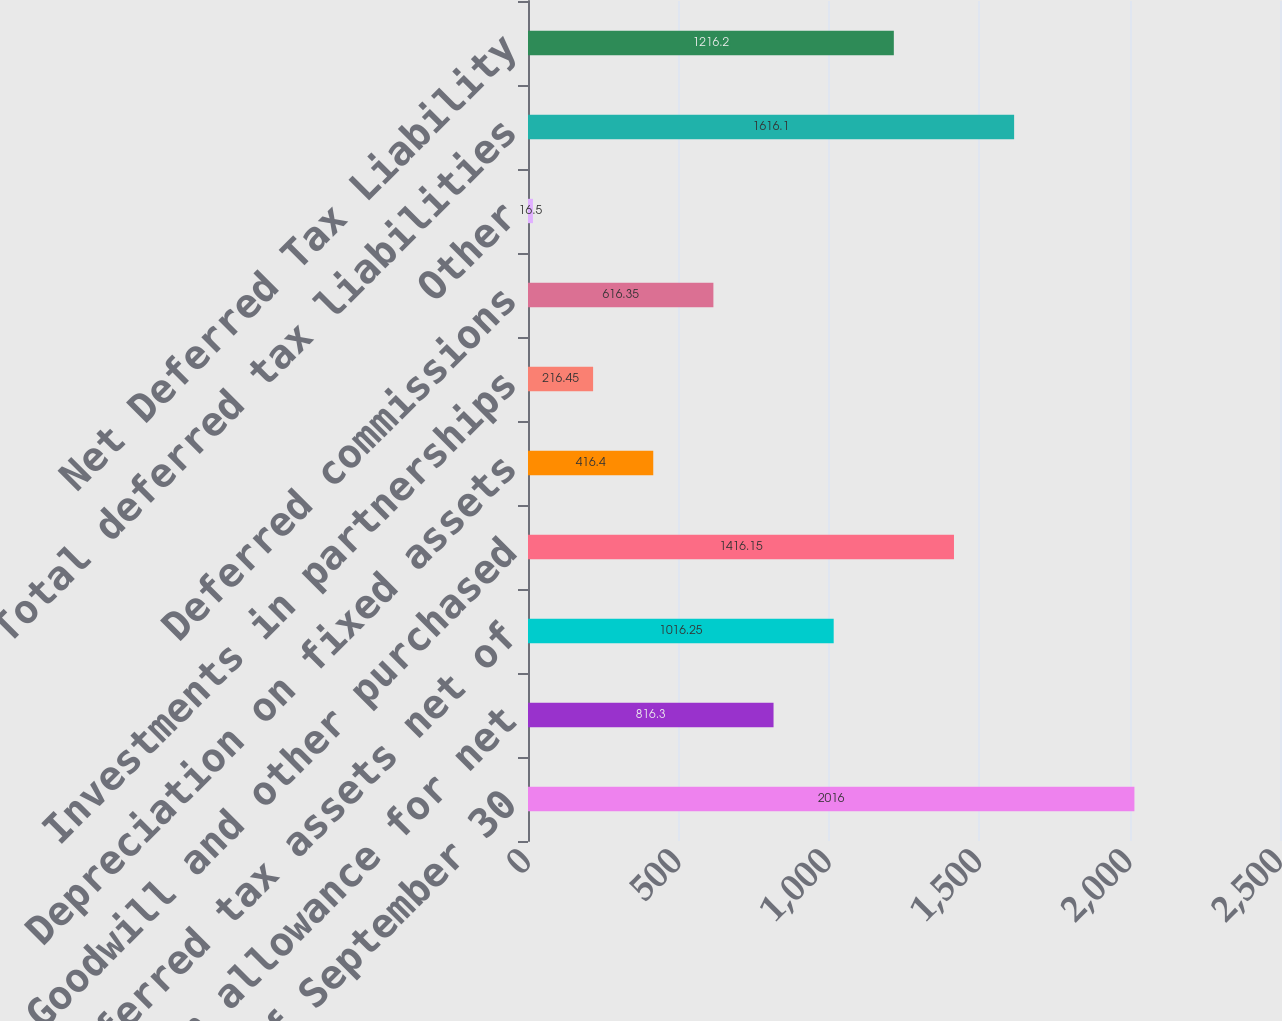Convert chart. <chart><loc_0><loc_0><loc_500><loc_500><bar_chart><fcel>as of September 30<fcel>Valuation allowance for net<fcel>Deferred tax assets net of<fcel>Goodwill and other purchased<fcel>Depreciation on fixed assets<fcel>Investments in partnerships<fcel>Deferred commissions<fcel>Other<fcel>Total deferred tax liabilities<fcel>Net Deferred Tax Liability<nl><fcel>2016<fcel>816.3<fcel>1016.25<fcel>1416.15<fcel>416.4<fcel>216.45<fcel>616.35<fcel>16.5<fcel>1616.1<fcel>1216.2<nl></chart> 